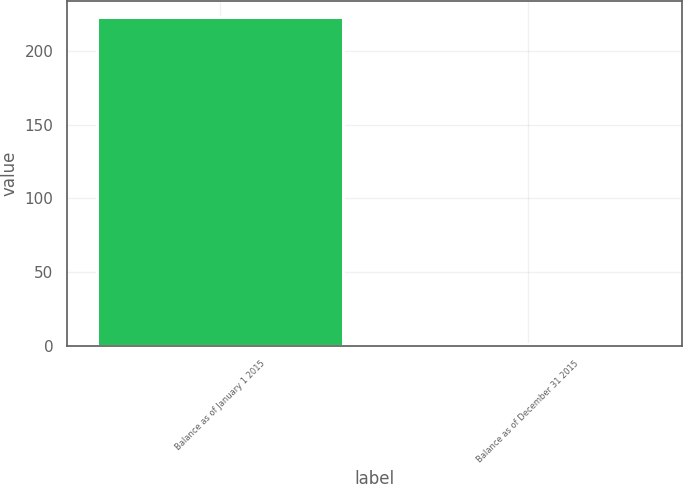Convert chart to OTSL. <chart><loc_0><loc_0><loc_500><loc_500><bar_chart><fcel>Balance as of January 1 2015<fcel>Balance as of December 31 2015<nl><fcel>223<fcel>1<nl></chart> 